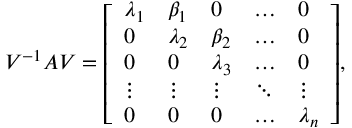Convert formula to latex. <formula><loc_0><loc_0><loc_500><loc_500>V ^ { - 1 } A V = { \left [ \begin{array} { l l l l l } { \lambda _ { 1 } } & { \beta _ { 1 } } & { 0 } & { \dots } & { 0 } \\ { 0 } & { \lambda _ { 2 } } & { \beta _ { 2 } } & { \dots } & { 0 } \\ { 0 } & { 0 } & { \lambda _ { 3 } } & { \dots } & { 0 } \\ { \vdots } & { \vdots } & { \vdots } & { \ddots } & { \vdots } \\ { 0 } & { 0 } & { 0 } & { \dots } & { \lambda _ { n } } \end{array} \right ] } ,</formula> 